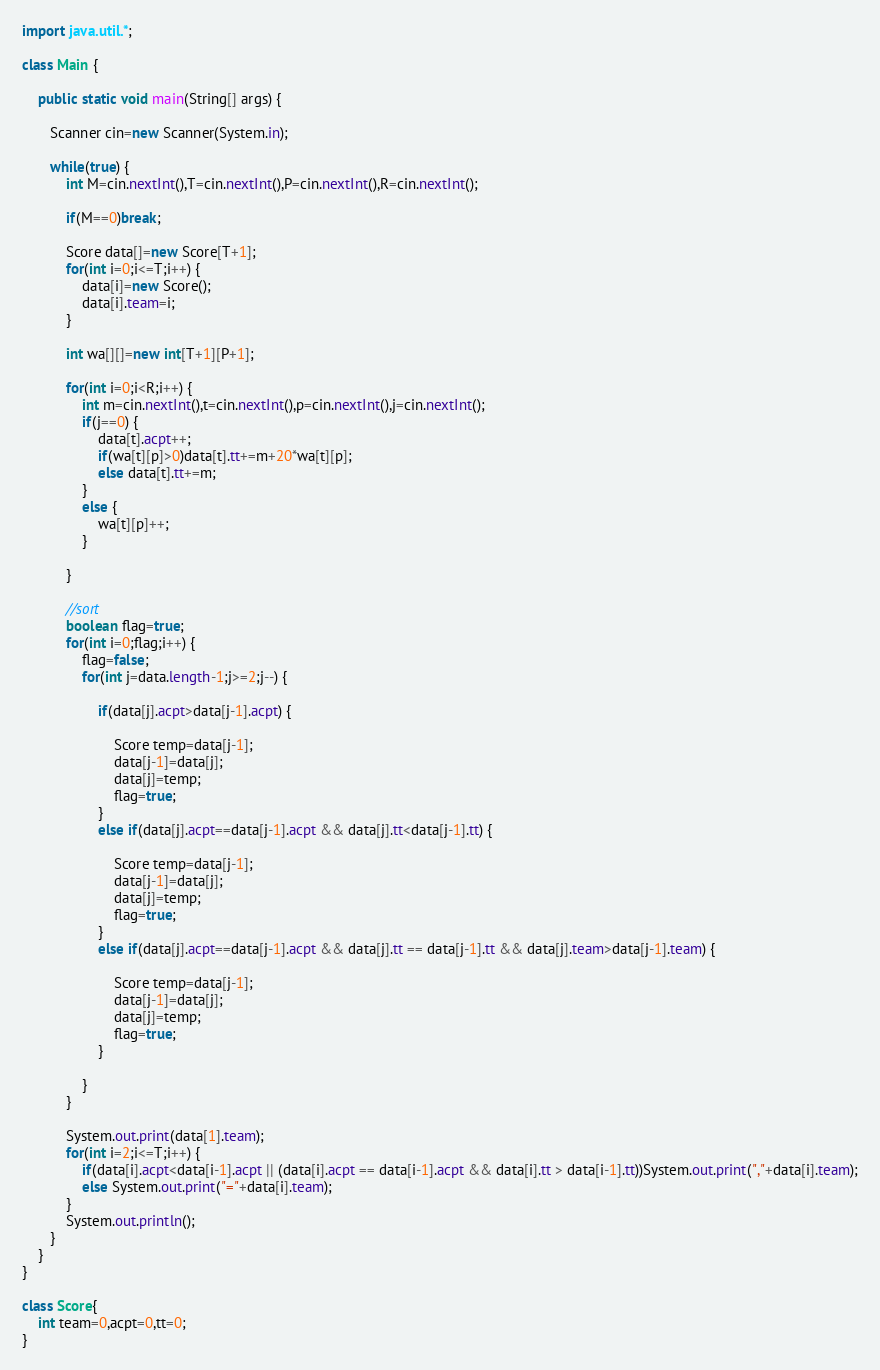Convert code to text. <code><loc_0><loc_0><loc_500><loc_500><_Java_>import java.util.*;
 
class Main {
	
    public static void main(String[] args) {
         
       Scanner cin=new Scanner(System.in);
       
       while(true) {
    	   int M=cin.nextInt(),T=cin.nextInt(),P=cin.nextInt(),R=cin.nextInt();
    	   
    	   if(M==0)break;
    	   
    	   Score data[]=new Score[T+1];
    	   for(int i=0;i<=T;i++) {
    		   data[i]=new Score();
    		   data[i].team=i;
    	   }
    	   
    	   int wa[][]=new int[T+1][P+1];
    	   
    	   for(int i=0;i<R;i++) {
    		   int m=cin.nextInt(),t=cin.nextInt(),p=cin.nextInt(),j=cin.nextInt();
    		   if(j==0) {
    			   data[t].acpt++;
    			   if(wa[t][p]>0)data[t].tt+=m+20*wa[t][p];
    			   else data[t].tt+=m;
    		   }
    		   else {
    			   wa[t][p]++;
    		   }
    		   
    	   }
    	   
    	   //sort
    	   boolean flag=true;
    	   for(int i=0;flag;i++) {
    		   flag=false;
    		   for(int j=data.length-1;j>=2;j--) {
    			   
    			   if(data[j].acpt>data[j-1].acpt) {
    				   
    				   Score temp=data[j-1];
    				   data[j-1]=data[j];
    				   data[j]=temp;
    				   flag=true;
    			   }
    			   else if(data[j].acpt==data[j-1].acpt && data[j].tt<data[j-1].tt) {
    				   
    				   Score temp=data[j-1];
    				   data[j-1]=data[j];
    				   data[j]=temp;
    				   flag=true;
    			   }
    			   else if(data[j].acpt==data[j-1].acpt && data[j].tt == data[j-1].tt && data[j].team>data[j-1].team) {
    				   
    				   Score temp=data[j-1];
    				   data[j-1]=data[j];
    				   data[j]=temp;
    				   flag=true;
    			   }
    			   
    		   }
    	   }
    	   
    	   System.out.print(data[1].team);
    	   for(int i=2;i<=T;i++) {
    		   if(data[i].acpt<data[i-1].acpt || (data[i].acpt == data[i-1].acpt && data[i].tt > data[i-1].tt))System.out.print(","+data[i].team);
    		   else System.out.print("="+data[i].team);
    	   }
    	   System.out.println();
       }
    }
}

class Score{
	int team=0,acpt=0,tt=0;
}
</code> 